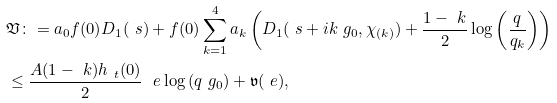<formula> <loc_0><loc_0><loc_500><loc_500>& \mathfrak { V } \colon = a _ { 0 } f ( 0 ) D _ { 1 } ( \ s ) + f ( 0 ) \sum _ { k = 1 } ^ { 4 } a _ { k } \left ( D _ { 1 } ( \ s + i k \ g _ { 0 } , \chi _ { ( k ) } ) + \frac { 1 - \ k } 2 \log \left ( \frac { q } { q _ { k } } \right ) \right ) \\ & \leq \frac { A ( 1 - \ k ) h _ { \ t } ( 0 ) } 2 \ \ e \log \left ( q \ g _ { 0 } \right ) + \mathfrak { v } ( \ e ) ,</formula> 